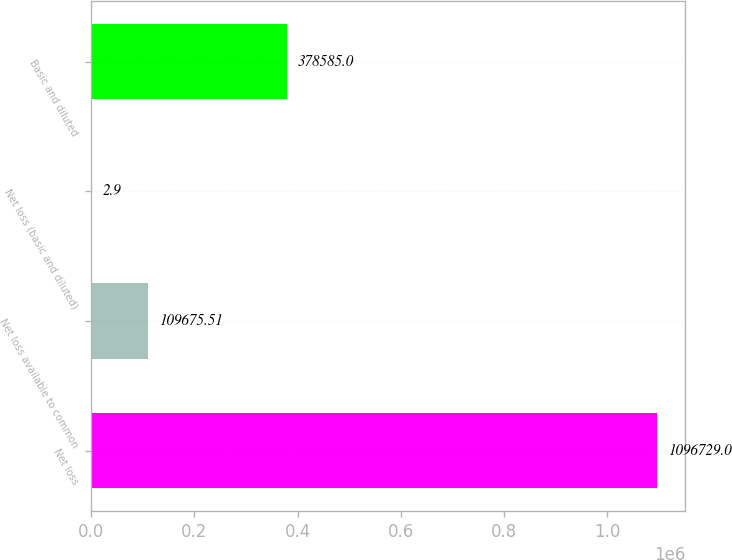Convert chart. <chart><loc_0><loc_0><loc_500><loc_500><bar_chart><fcel>Net loss<fcel>Net loss available to common<fcel>Net loss (basic and diluted)<fcel>Basic and diluted<nl><fcel>1.09673e+06<fcel>109676<fcel>2.9<fcel>378585<nl></chart> 